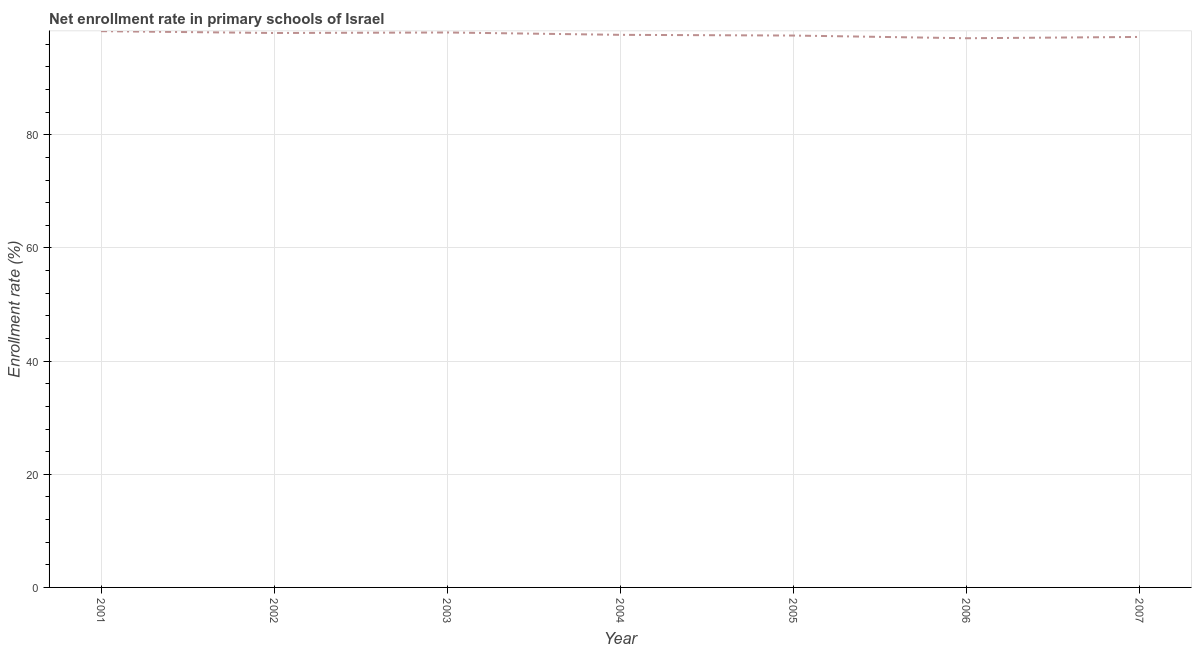What is the net enrollment rate in primary schools in 2003?
Provide a short and direct response. 98.08. Across all years, what is the maximum net enrollment rate in primary schools?
Provide a succinct answer. 98.31. Across all years, what is the minimum net enrollment rate in primary schools?
Your answer should be very brief. 97.06. What is the sum of the net enrollment rate in primary schools?
Your answer should be compact. 683.94. What is the difference between the net enrollment rate in primary schools in 2005 and 2007?
Your answer should be very brief. 0.25. What is the average net enrollment rate in primary schools per year?
Your response must be concise. 97.71. What is the median net enrollment rate in primary schools?
Your response must be concise. 97.66. Do a majority of the years between 2001 and 2003 (inclusive) have net enrollment rate in primary schools greater than 28 %?
Your answer should be very brief. Yes. What is the ratio of the net enrollment rate in primary schools in 2002 to that in 2007?
Your answer should be compact. 1.01. Is the net enrollment rate in primary schools in 2001 less than that in 2003?
Your answer should be compact. No. What is the difference between the highest and the second highest net enrollment rate in primary schools?
Your answer should be very brief. 0.23. Is the sum of the net enrollment rate in primary schools in 2003 and 2006 greater than the maximum net enrollment rate in primary schools across all years?
Your answer should be very brief. Yes. What is the difference between the highest and the lowest net enrollment rate in primary schools?
Make the answer very short. 1.25. In how many years, is the net enrollment rate in primary schools greater than the average net enrollment rate in primary schools taken over all years?
Provide a succinct answer. 3. Does the net enrollment rate in primary schools monotonically increase over the years?
Keep it short and to the point. No. How many years are there in the graph?
Provide a succinct answer. 7. Does the graph contain grids?
Give a very brief answer. Yes. What is the title of the graph?
Give a very brief answer. Net enrollment rate in primary schools of Israel. What is the label or title of the X-axis?
Your answer should be compact. Year. What is the label or title of the Y-axis?
Give a very brief answer. Enrollment rate (%). What is the Enrollment rate (%) of 2001?
Offer a very short reply. 98.31. What is the Enrollment rate (%) of 2002?
Provide a short and direct response. 97.99. What is the Enrollment rate (%) in 2003?
Make the answer very short. 98.08. What is the Enrollment rate (%) in 2004?
Your answer should be very brief. 97.66. What is the Enrollment rate (%) in 2005?
Offer a terse response. 97.54. What is the Enrollment rate (%) in 2006?
Ensure brevity in your answer.  97.06. What is the Enrollment rate (%) of 2007?
Make the answer very short. 97.29. What is the difference between the Enrollment rate (%) in 2001 and 2002?
Your response must be concise. 0.32. What is the difference between the Enrollment rate (%) in 2001 and 2003?
Keep it short and to the point. 0.23. What is the difference between the Enrollment rate (%) in 2001 and 2004?
Keep it short and to the point. 0.65. What is the difference between the Enrollment rate (%) in 2001 and 2005?
Offer a very short reply. 0.77. What is the difference between the Enrollment rate (%) in 2001 and 2006?
Offer a terse response. 1.25. What is the difference between the Enrollment rate (%) in 2001 and 2007?
Ensure brevity in your answer.  1.02. What is the difference between the Enrollment rate (%) in 2002 and 2003?
Offer a terse response. -0.09. What is the difference between the Enrollment rate (%) in 2002 and 2004?
Offer a terse response. 0.33. What is the difference between the Enrollment rate (%) in 2002 and 2005?
Your answer should be very brief. 0.45. What is the difference between the Enrollment rate (%) in 2002 and 2006?
Offer a very short reply. 0.93. What is the difference between the Enrollment rate (%) in 2002 and 2007?
Make the answer very short. 0.7. What is the difference between the Enrollment rate (%) in 2003 and 2004?
Offer a very short reply. 0.42. What is the difference between the Enrollment rate (%) in 2003 and 2005?
Your response must be concise. 0.54. What is the difference between the Enrollment rate (%) in 2003 and 2006?
Give a very brief answer. 1.02. What is the difference between the Enrollment rate (%) in 2003 and 2007?
Give a very brief answer. 0.79. What is the difference between the Enrollment rate (%) in 2004 and 2005?
Your answer should be compact. 0.12. What is the difference between the Enrollment rate (%) in 2004 and 2006?
Your answer should be compact. 0.6. What is the difference between the Enrollment rate (%) in 2004 and 2007?
Provide a short and direct response. 0.37. What is the difference between the Enrollment rate (%) in 2005 and 2006?
Provide a short and direct response. 0.48. What is the difference between the Enrollment rate (%) in 2005 and 2007?
Your answer should be very brief. 0.25. What is the difference between the Enrollment rate (%) in 2006 and 2007?
Ensure brevity in your answer.  -0.23. What is the ratio of the Enrollment rate (%) in 2001 to that in 2007?
Offer a terse response. 1.01. What is the ratio of the Enrollment rate (%) in 2002 to that in 2003?
Provide a succinct answer. 1. What is the ratio of the Enrollment rate (%) in 2002 to that in 2005?
Offer a very short reply. 1. What is the ratio of the Enrollment rate (%) in 2002 to that in 2006?
Offer a very short reply. 1.01. What is the ratio of the Enrollment rate (%) in 2002 to that in 2007?
Your answer should be compact. 1.01. What is the ratio of the Enrollment rate (%) in 2003 to that in 2007?
Offer a terse response. 1.01. What is the ratio of the Enrollment rate (%) in 2004 to that in 2007?
Your answer should be compact. 1. What is the ratio of the Enrollment rate (%) in 2006 to that in 2007?
Provide a succinct answer. 1. 